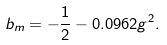<formula> <loc_0><loc_0><loc_500><loc_500>b _ { m } = - \frac { 1 } { 2 } - 0 . 0 9 6 2 g ^ { 2 } .</formula> 